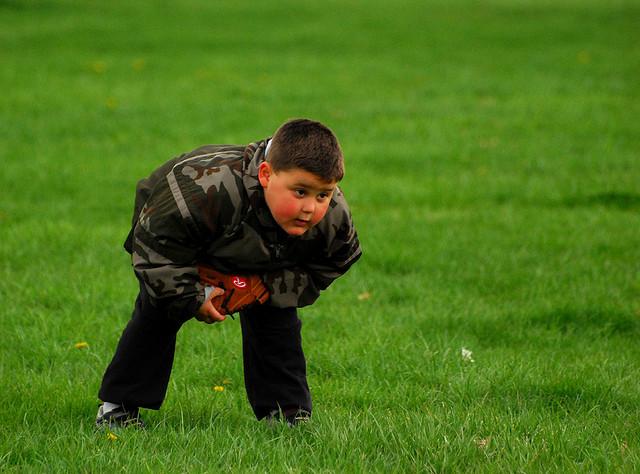Is that a boy or a girl?
Short answer required. Boy. Is the possibly a baseball field?
Answer briefly. Yes. Is the child wearing Camo?
Quick response, please. Yes. What color is the pants?
Be succinct. Black. What sport is the boy playing?
Give a very brief answer. Baseball. Who is in the photo?
Answer briefly. Boy. Who will catch the ball?
Be succinct. Boy. 